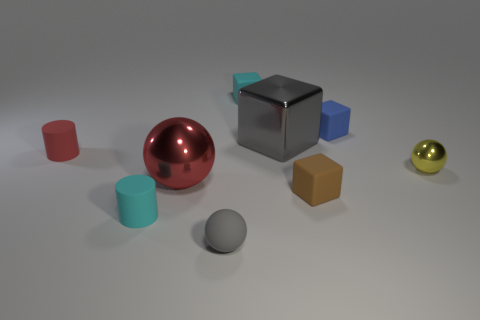Add 1 small green rubber blocks. How many objects exist? 10 Subtract all blocks. How many objects are left? 5 Subtract all yellow spheres. Subtract all tiny matte blocks. How many objects are left? 5 Add 6 blue cubes. How many blue cubes are left? 7 Add 1 big cyan matte cylinders. How many big cyan matte cylinders exist? 1 Subtract 0 brown cylinders. How many objects are left? 9 